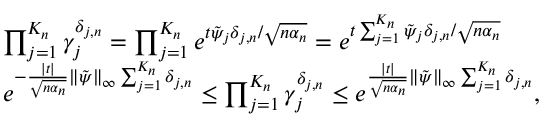Convert formula to latex. <formula><loc_0><loc_0><loc_500><loc_500>\begin{array} { r l } & { \prod _ { j = 1 } ^ { K _ { n } } \gamma _ { j } ^ { \delta _ { j , n } } = \prod _ { j = 1 } ^ { K _ { n } } e ^ { t \tilde { \psi } _ { j } \delta _ { j , n } / \sqrt { n \alpha _ { n } } } = e ^ { t \sum _ { j = 1 } ^ { K _ { n } } \tilde { \psi } _ { j } \delta _ { j , n } / \sqrt { n \alpha _ { n } } } } \\ & { e ^ { - \frac { | t | } { \sqrt { n \alpha _ { n } } } \| \tilde { \psi } \| _ { \infty } \sum _ { j = 1 } ^ { K _ { n } } \delta _ { j , n } } \leq \prod _ { j = 1 } ^ { K _ { n } } \gamma _ { j } ^ { \delta _ { j , n } } \leq e ^ { \frac { | t | } { \sqrt { n \alpha _ { n } } } \| \tilde { \psi } \| _ { \infty } \sum _ { j = 1 } ^ { K _ { n } } \delta _ { j , n } } , } \end{array}</formula> 